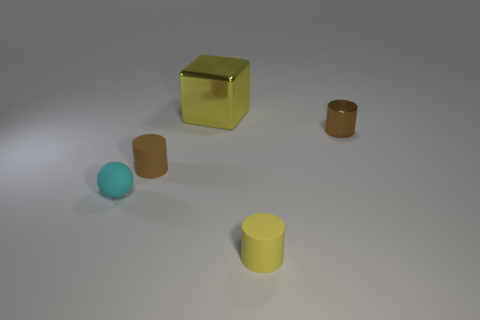Subtract all tiny brown cylinders. How many cylinders are left? 1 Add 3 brown objects. How many objects exist? 8 Subtract all brown cylinders. How many cylinders are left? 1 Subtract 3 cylinders. How many cylinders are left? 0 Subtract all yellow cylinders. Subtract all purple blocks. How many cylinders are left? 2 Subtract all yellow cylinders. How many yellow balls are left? 0 Subtract all big green metallic cubes. Subtract all large things. How many objects are left? 4 Add 4 tiny yellow rubber things. How many tiny yellow rubber things are left? 5 Add 1 large brown rubber objects. How many large brown rubber objects exist? 1 Subtract 0 gray cylinders. How many objects are left? 5 